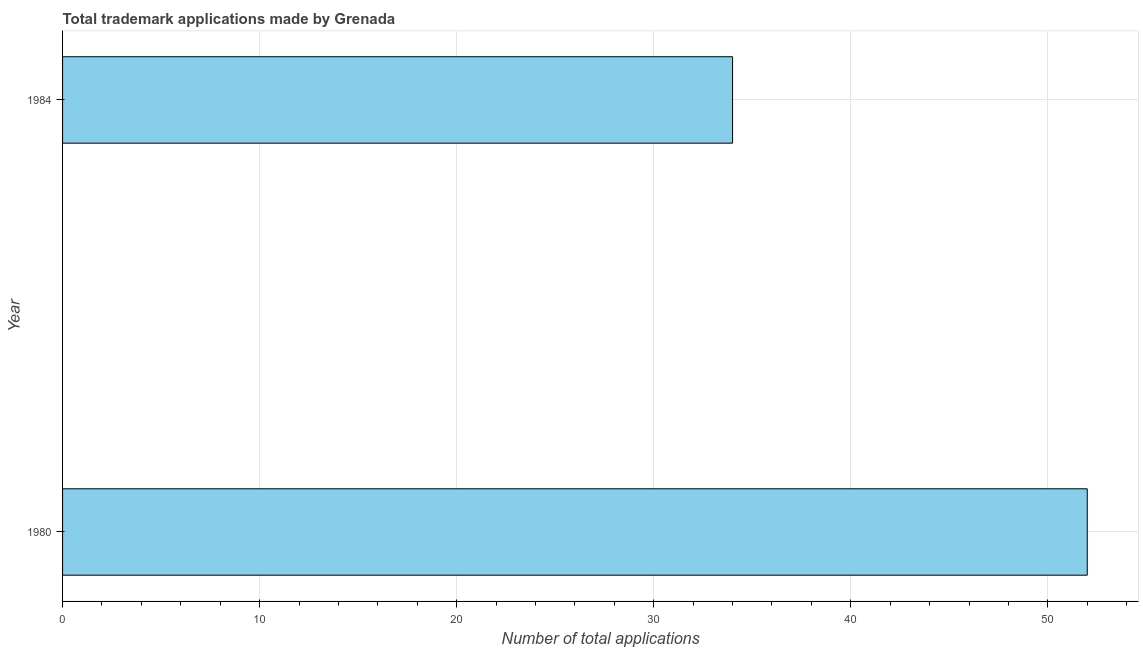Does the graph contain any zero values?
Your answer should be compact. No. What is the title of the graph?
Your response must be concise. Total trademark applications made by Grenada. What is the label or title of the X-axis?
Offer a very short reply. Number of total applications. Across all years, what is the maximum number of trademark applications?
Offer a very short reply. 52. Across all years, what is the minimum number of trademark applications?
Make the answer very short. 34. In which year was the number of trademark applications maximum?
Ensure brevity in your answer.  1980. What is the average number of trademark applications per year?
Make the answer very short. 43. What is the median number of trademark applications?
Ensure brevity in your answer.  43. In how many years, is the number of trademark applications greater than 24 ?
Ensure brevity in your answer.  2. Do a majority of the years between 1984 and 1980 (inclusive) have number of trademark applications greater than 18 ?
Provide a succinct answer. No. What is the ratio of the number of trademark applications in 1980 to that in 1984?
Keep it short and to the point. 1.53. In how many years, is the number of trademark applications greater than the average number of trademark applications taken over all years?
Provide a succinct answer. 1. Are all the bars in the graph horizontal?
Provide a succinct answer. Yes. How many years are there in the graph?
Keep it short and to the point. 2. What is the difference between two consecutive major ticks on the X-axis?
Make the answer very short. 10. Are the values on the major ticks of X-axis written in scientific E-notation?
Keep it short and to the point. No. What is the Number of total applications in 1980?
Your answer should be very brief. 52. What is the difference between the Number of total applications in 1980 and 1984?
Your response must be concise. 18. What is the ratio of the Number of total applications in 1980 to that in 1984?
Your response must be concise. 1.53. 